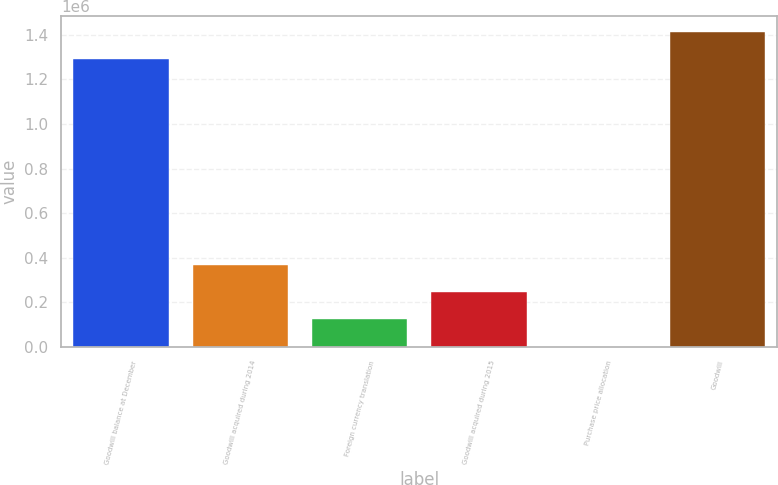Convert chart. <chart><loc_0><loc_0><loc_500><loc_500><bar_chart><fcel>Goodwill balance at December<fcel>Goodwill acquired during 2014<fcel>Foreign currency translation<fcel>Goodwill acquired during 2015<fcel>Purchase price allocation<fcel>Goodwill<nl><fcel>1.29063e+06<fcel>368398<fcel>123300<fcel>245849<fcel>750<fcel>1.41318e+06<nl></chart> 